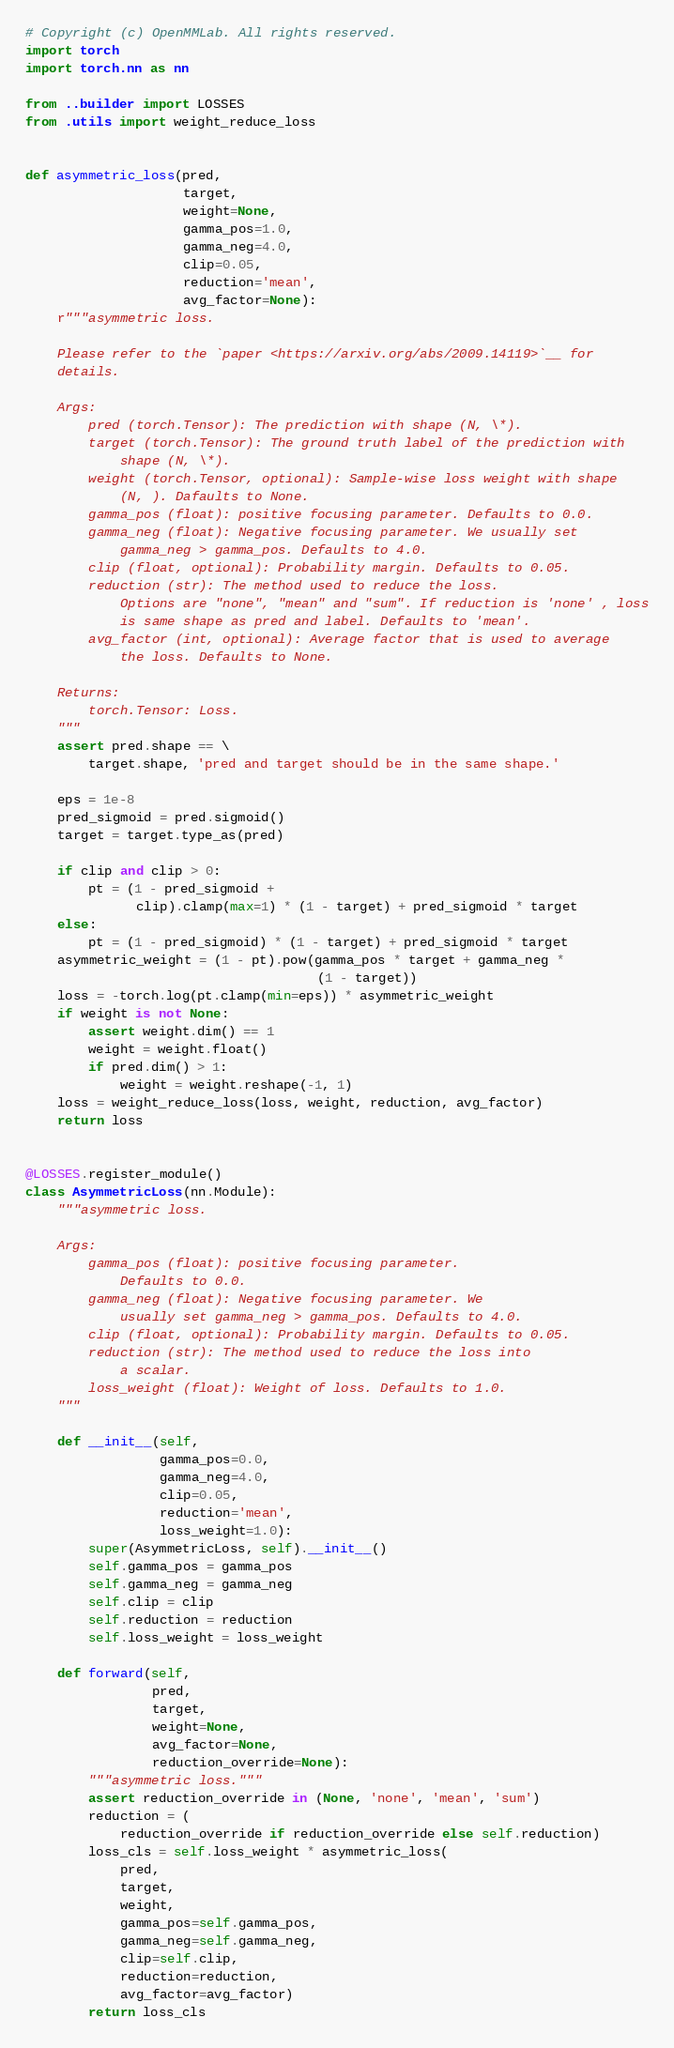<code> <loc_0><loc_0><loc_500><loc_500><_Python_># Copyright (c) OpenMMLab. All rights reserved.
import torch
import torch.nn as nn

from ..builder import LOSSES
from .utils import weight_reduce_loss


def asymmetric_loss(pred,
                    target,
                    weight=None,
                    gamma_pos=1.0,
                    gamma_neg=4.0,
                    clip=0.05,
                    reduction='mean',
                    avg_factor=None):
    r"""asymmetric loss.

    Please refer to the `paper <https://arxiv.org/abs/2009.14119>`__ for
    details.

    Args:
        pred (torch.Tensor): The prediction with shape (N, \*).
        target (torch.Tensor): The ground truth label of the prediction with
            shape (N, \*).
        weight (torch.Tensor, optional): Sample-wise loss weight with shape
            (N, ). Dafaults to None.
        gamma_pos (float): positive focusing parameter. Defaults to 0.0.
        gamma_neg (float): Negative focusing parameter. We usually set
            gamma_neg > gamma_pos. Defaults to 4.0.
        clip (float, optional): Probability margin. Defaults to 0.05.
        reduction (str): The method used to reduce the loss.
            Options are "none", "mean" and "sum". If reduction is 'none' , loss
            is same shape as pred and label. Defaults to 'mean'.
        avg_factor (int, optional): Average factor that is used to average
            the loss. Defaults to None.

    Returns:
        torch.Tensor: Loss.
    """
    assert pred.shape == \
        target.shape, 'pred and target should be in the same shape.'

    eps = 1e-8
    pred_sigmoid = pred.sigmoid()
    target = target.type_as(pred)

    if clip and clip > 0:
        pt = (1 - pred_sigmoid +
              clip).clamp(max=1) * (1 - target) + pred_sigmoid * target
    else:
        pt = (1 - pred_sigmoid) * (1 - target) + pred_sigmoid * target
    asymmetric_weight = (1 - pt).pow(gamma_pos * target + gamma_neg *
                                     (1 - target))
    loss = -torch.log(pt.clamp(min=eps)) * asymmetric_weight
    if weight is not None:
        assert weight.dim() == 1
        weight = weight.float()
        if pred.dim() > 1:
            weight = weight.reshape(-1, 1)
    loss = weight_reduce_loss(loss, weight, reduction, avg_factor)
    return loss


@LOSSES.register_module()
class AsymmetricLoss(nn.Module):
    """asymmetric loss.

    Args:
        gamma_pos (float): positive focusing parameter.
            Defaults to 0.0.
        gamma_neg (float): Negative focusing parameter. We
            usually set gamma_neg > gamma_pos. Defaults to 4.0.
        clip (float, optional): Probability margin. Defaults to 0.05.
        reduction (str): The method used to reduce the loss into
            a scalar.
        loss_weight (float): Weight of loss. Defaults to 1.0.
    """

    def __init__(self,
                 gamma_pos=0.0,
                 gamma_neg=4.0,
                 clip=0.05,
                 reduction='mean',
                 loss_weight=1.0):
        super(AsymmetricLoss, self).__init__()
        self.gamma_pos = gamma_pos
        self.gamma_neg = gamma_neg
        self.clip = clip
        self.reduction = reduction
        self.loss_weight = loss_weight

    def forward(self,
                pred,
                target,
                weight=None,
                avg_factor=None,
                reduction_override=None):
        """asymmetric loss."""
        assert reduction_override in (None, 'none', 'mean', 'sum')
        reduction = (
            reduction_override if reduction_override else self.reduction)
        loss_cls = self.loss_weight * asymmetric_loss(
            pred,
            target,
            weight,
            gamma_pos=self.gamma_pos,
            gamma_neg=self.gamma_neg,
            clip=self.clip,
            reduction=reduction,
            avg_factor=avg_factor)
        return loss_cls
</code> 